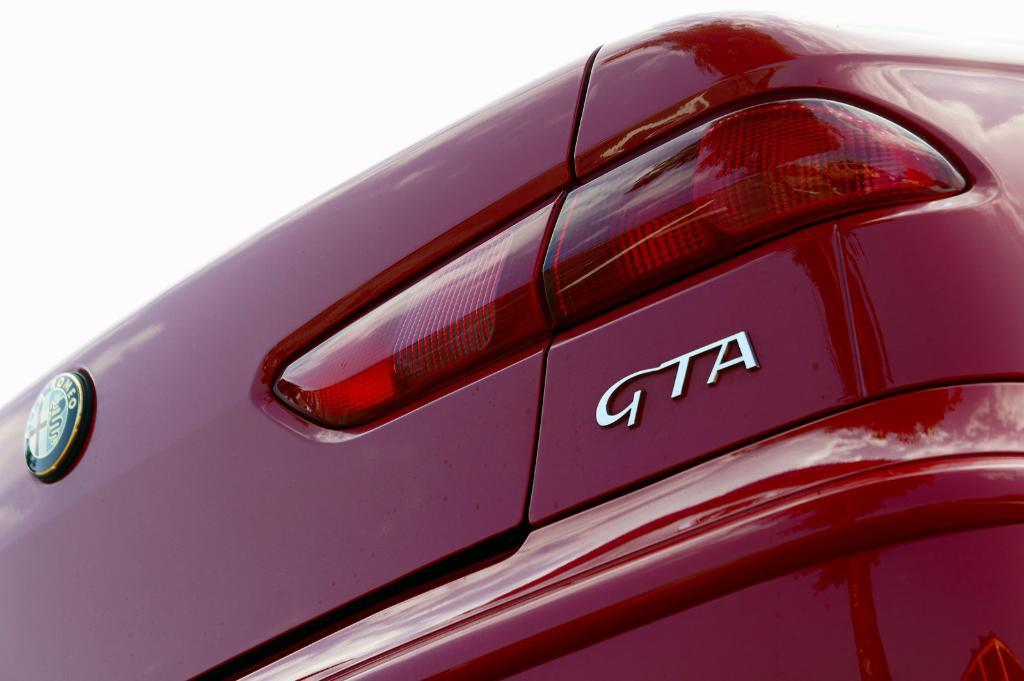What is the main subject of the image? The main subject of the image is a vehicle part. Can you describe the text on the vehicle part? Yes, there is text written on the vehicle part. What color is the background of the image? The background of the image is white. What type of pet can be seen playing with the yoke in the image? There is no pet or yoke present in the image; it features a vehicle part with text on it. 